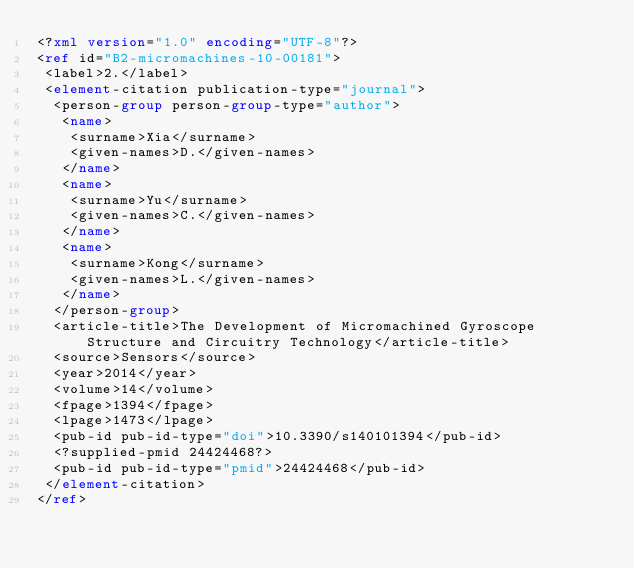<code> <loc_0><loc_0><loc_500><loc_500><_XML_><?xml version="1.0" encoding="UTF-8"?>
<ref id="B2-micromachines-10-00181">
 <label>2.</label>
 <element-citation publication-type="journal">
  <person-group person-group-type="author">
   <name>
    <surname>Xia</surname>
    <given-names>D.</given-names>
   </name>
   <name>
    <surname>Yu</surname>
    <given-names>C.</given-names>
   </name>
   <name>
    <surname>Kong</surname>
    <given-names>L.</given-names>
   </name>
  </person-group>
  <article-title>The Development of Micromachined Gyroscope Structure and Circuitry Technology</article-title>
  <source>Sensors</source>
  <year>2014</year>
  <volume>14</volume>
  <fpage>1394</fpage>
  <lpage>1473</lpage>
  <pub-id pub-id-type="doi">10.3390/s140101394</pub-id>
  <?supplied-pmid 24424468?>
  <pub-id pub-id-type="pmid">24424468</pub-id>
 </element-citation>
</ref>
</code> 